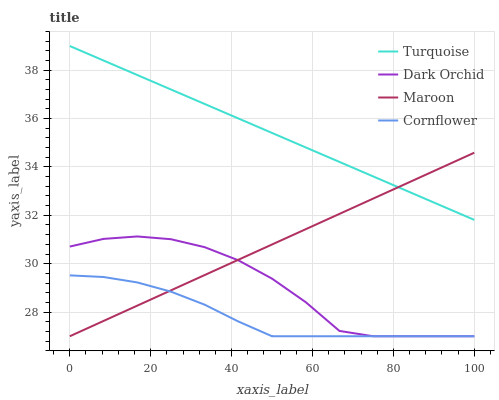Does Cornflower have the minimum area under the curve?
Answer yes or no. Yes. Does Turquoise have the maximum area under the curve?
Answer yes or no. Yes. Does Maroon have the minimum area under the curve?
Answer yes or no. No. Does Maroon have the maximum area under the curve?
Answer yes or no. No. Is Maroon the smoothest?
Answer yes or no. Yes. Is Dark Orchid the roughest?
Answer yes or no. Yes. Is Turquoise the smoothest?
Answer yes or no. No. Is Turquoise the roughest?
Answer yes or no. No. Does Cornflower have the lowest value?
Answer yes or no. Yes. Does Turquoise have the lowest value?
Answer yes or no. No. Does Turquoise have the highest value?
Answer yes or no. Yes. Does Maroon have the highest value?
Answer yes or no. No. Is Dark Orchid less than Turquoise?
Answer yes or no. Yes. Is Turquoise greater than Cornflower?
Answer yes or no. Yes. Does Cornflower intersect Maroon?
Answer yes or no. Yes. Is Cornflower less than Maroon?
Answer yes or no. No. Is Cornflower greater than Maroon?
Answer yes or no. No. Does Dark Orchid intersect Turquoise?
Answer yes or no. No. 